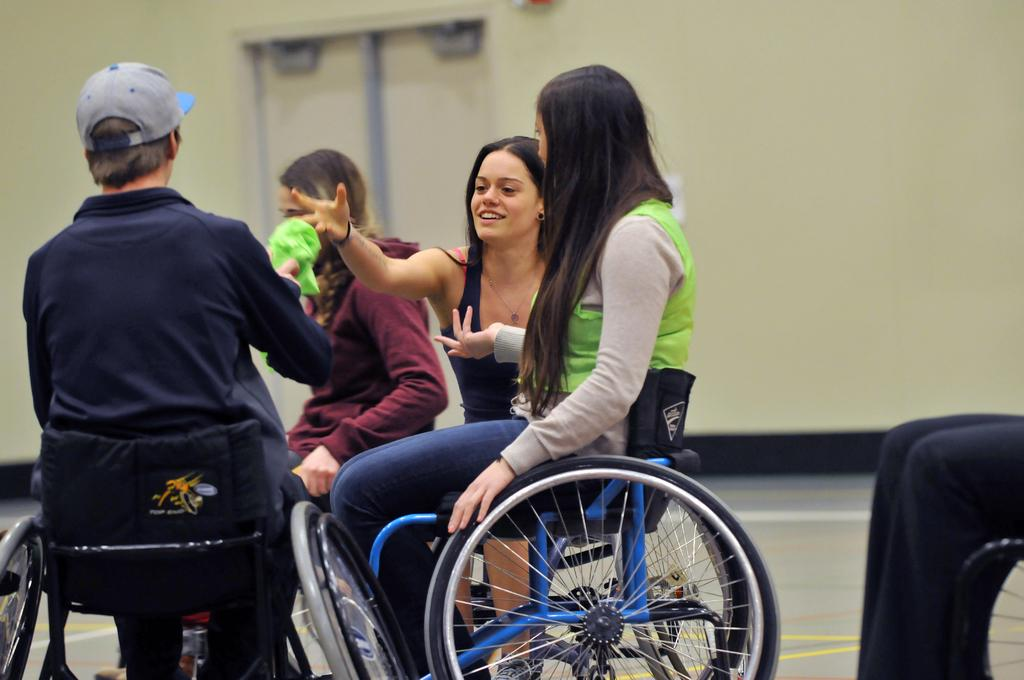How many persons are sitting on wheelchairs in the image? There are four persons sitting on wheelchairs in the image. Is there a possibility of another person on a wheelchair in the image? Yes, there may be another person on a wheelchair in the bottom right corner of the image. What can be seen in the background of the image? There is a wall in the background of the image. What type of afterthought is visible in the image? There is no afterthought visible in the image. What kind of border surrounds the image? The image does not show a border; it is a photograph or illustration with its own edges. 